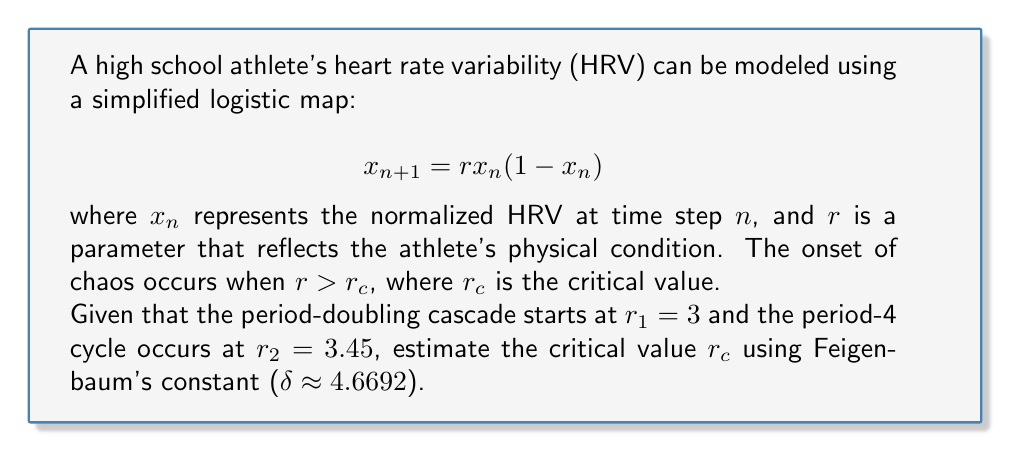Give your solution to this math problem. To solve this problem, we'll use Feigenbaum's constant and the period-doubling cascade concept:

1) Feigenbaum's constant relates successive period-doubling bifurcations:

   $$\delta = \lim_{n \to \infty} \frac{r_n - r_{n-1}}{r_{n+1} - r_n}$$

2) We're given two points in the period-doubling cascade:
   $r_1 = 3$ (period-2)
   $r_2 = 3.45$ (period-4)

3) Let's assume $r_3$ is the period-8 point, and $r_c$ is the accumulation point (onset of chaos).

4) Using Feigenbaum's constant, we can set up the equation:

   $$\delta \approx \frac{r_2 - r_1}{r_3 - r_2} \approx \frac{r_3 - r_2}{r_c - r_3}$$

5) From the first equality:
   
   $$r_3 \approx r_2 + \frac{r_2 - r_1}{\delta} = 3.45 + \frac{3.45 - 3}{4.6692} \approx 3.5471$$

6) Now, using the second equality:

   $$4.6692 \approx \frac{3.5471 - 3.45}{r_c - 3.5471}$$

7) Solving for $r_c$:

   $$r_c \approx 3.5471 + \frac{3.5471 - 3.45}{4.6692} \approx 3.5700$$

Thus, we estimate the critical value $r_c$ to be approximately 3.5700.
Answer: $r_c \approx 3.5700$ 